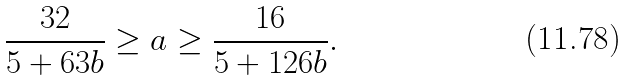<formula> <loc_0><loc_0><loc_500><loc_500>\frac { 3 2 } { 5 + 6 3 b } \geq a & \geq \frac { 1 6 } { 5 + 1 2 6 b } .</formula> 